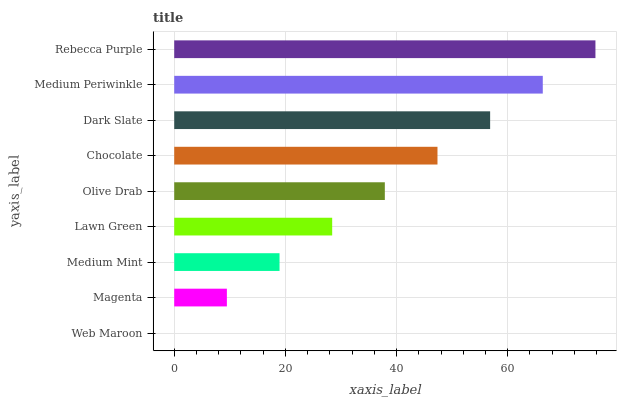Is Web Maroon the minimum?
Answer yes or no. Yes. Is Rebecca Purple the maximum?
Answer yes or no. Yes. Is Magenta the minimum?
Answer yes or no. No. Is Magenta the maximum?
Answer yes or no. No. Is Magenta greater than Web Maroon?
Answer yes or no. Yes. Is Web Maroon less than Magenta?
Answer yes or no. Yes. Is Web Maroon greater than Magenta?
Answer yes or no. No. Is Magenta less than Web Maroon?
Answer yes or no. No. Is Olive Drab the high median?
Answer yes or no. Yes. Is Olive Drab the low median?
Answer yes or no. Yes. Is Rebecca Purple the high median?
Answer yes or no. No. Is Medium Mint the low median?
Answer yes or no. No. 